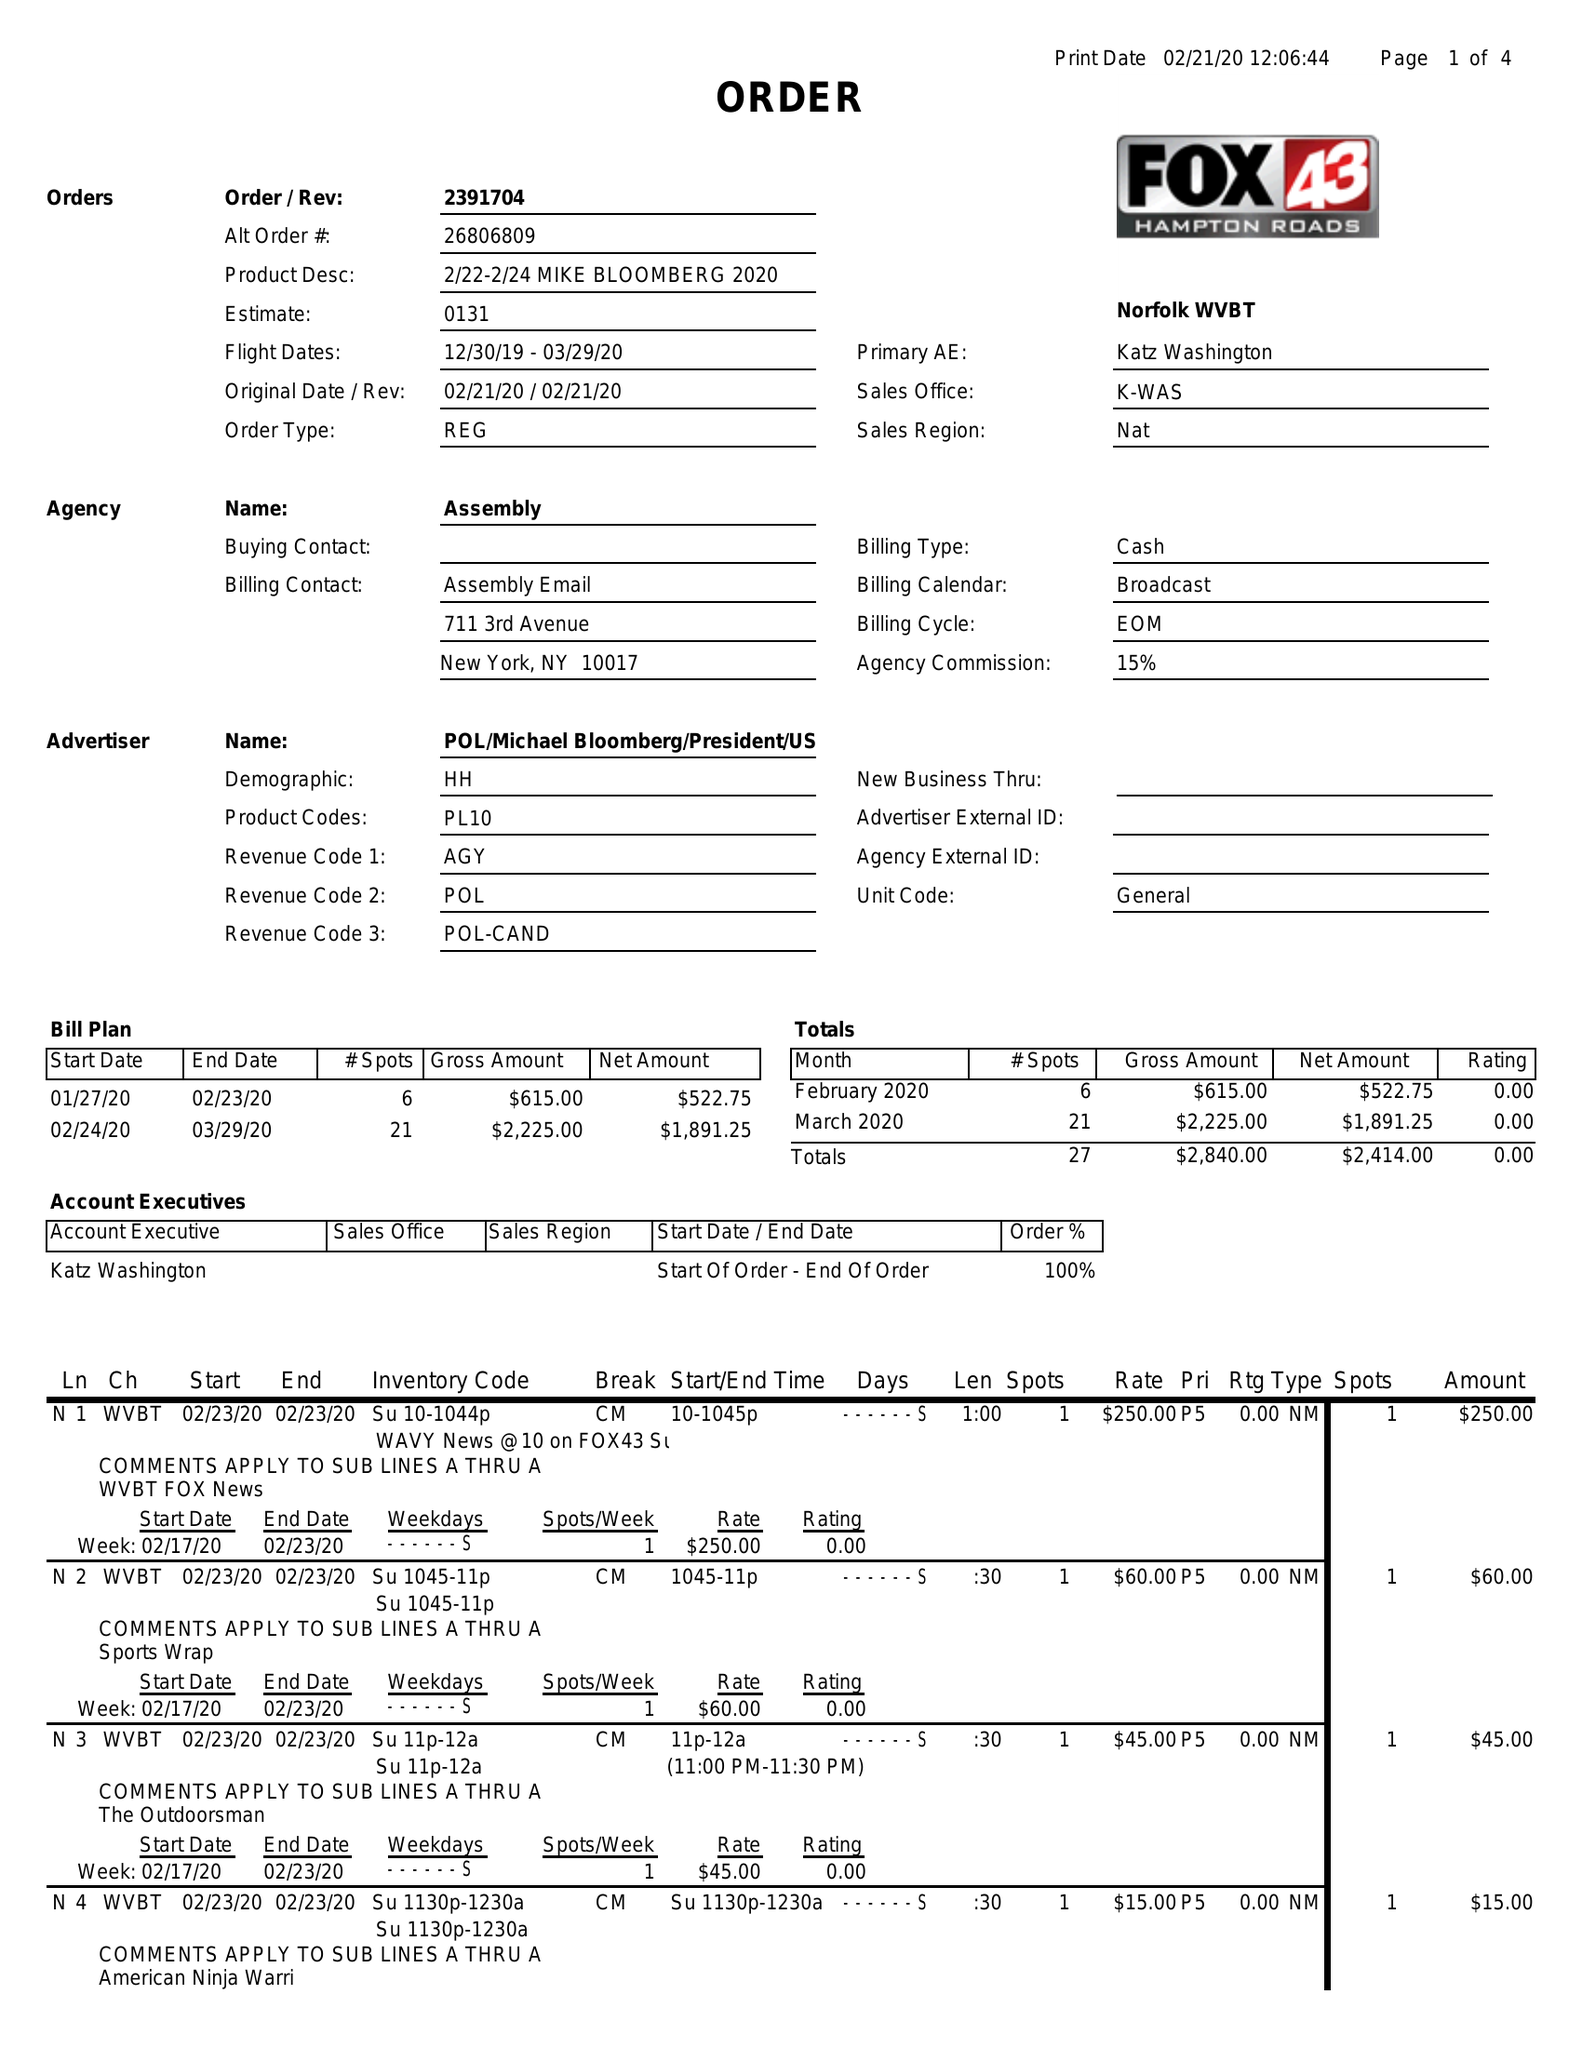What is the value for the contract_num?
Answer the question using a single word or phrase. 239170412 